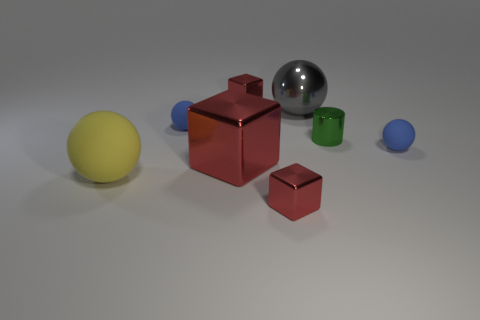How many red blocks are right of the large metallic ball?
Provide a succinct answer. 0. What number of matte balls are the same color as the big metal block?
Your answer should be compact. 0. Is the material of the cube that is behind the gray object the same as the large block?
Offer a terse response. Yes. What number of large gray balls are the same material as the yellow ball?
Your answer should be compact. 0. Are there more green metallic objects that are behind the cylinder than tiny red things?
Your response must be concise. No. Are there any tiny things that have the same shape as the large red shiny thing?
Your answer should be very brief. Yes. How many things are yellow balls or shiny cylinders?
Ensure brevity in your answer.  2. There is a big ball that is to the left of the small red shiny object in front of the gray sphere; what number of large objects are right of it?
Ensure brevity in your answer.  2. There is another large object that is the same shape as the large yellow object; what is it made of?
Give a very brief answer. Metal. There is a small object that is right of the big red block and behind the green thing; what material is it?
Give a very brief answer. Metal. 